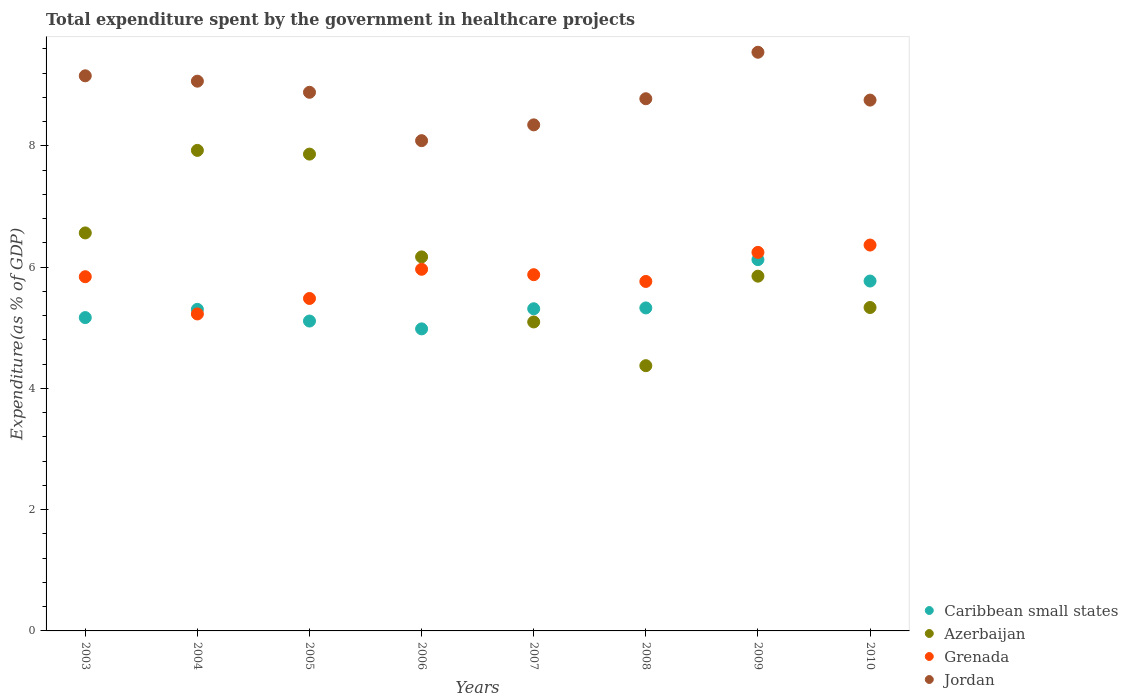How many different coloured dotlines are there?
Your answer should be very brief. 4. What is the total expenditure spent by the government in healthcare projects in Jordan in 2008?
Your answer should be very brief. 8.78. Across all years, what is the maximum total expenditure spent by the government in healthcare projects in Grenada?
Your answer should be very brief. 6.36. Across all years, what is the minimum total expenditure spent by the government in healthcare projects in Grenada?
Offer a very short reply. 5.23. What is the total total expenditure spent by the government in healthcare projects in Azerbaijan in the graph?
Provide a succinct answer. 49.17. What is the difference between the total expenditure spent by the government in healthcare projects in Azerbaijan in 2005 and that in 2006?
Provide a succinct answer. 1.7. What is the difference between the total expenditure spent by the government in healthcare projects in Jordan in 2003 and the total expenditure spent by the government in healthcare projects in Grenada in 2009?
Make the answer very short. 2.91. What is the average total expenditure spent by the government in healthcare projects in Grenada per year?
Your answer should be very brief. 5.84. In the year 2007, what is the difference between the total expenditure spent by the government in healthcare projects in Grenada and total expenditure spent by the government in healthcare projects in Azerbaijan?
Your answer should be very brief. 0.78. In how many years, is the total expenditure spent by the government in healthcare projects in Caribbean small states greater than 2.8 %?
Your response must be concise. 8. What is the ratio of the total expenditure spent by the government in healthcare projects in Grenada in 2007 to that in 2009?
Ensure brevity in your answer.  0.94. Is the total expenditure spent by the government in healthcare projects in Azerbaijan in 2007 less than that in 2010?
Keep it short and to the point. Yes. What is the difference between the highest and the second highest total expenditure spent by the government in healthcare projects in Azerbaijan?
Make the answer very short. 0.06. What is the difference between the highest and the lowest total expenditure spent by the government in healthcare projects in Azerbaijan?
Provide a succinct answer. 3.55. Is the sum of the total expenditure spent by the government in healthcare projects in Grenada in 2005 and 2009 greater than the maximum total expenditure spent by the government in healthcare projects in Caribbean small states across all years?
Your answer should be compact. Yes. Is it the case that in every year, the sum of the total expenditure spent by the government in healthcare projects in Jordan and total expenditure spent by the government in healthcare projects in Grenada  is greater than the total expenditure spent by the government in healthcare projects in Azerbaijan?
Your answer should be very brief. Yes. Is the total expenditure spent by the government in healthcare projects in Azerbaijan strictly greater than the total expenditure spent by the government in healthcare projects in Jordan over the years?
Your response must be concise. No. Is the total expenditure spent by the government in healthcare projects in Grenada strictly less than the total expenditure spent by the government in healthcare projects in Caribbean small states over the years?
Offer a terse response. No. How many years are there in the graph?
Your response must be concise. 8. Where does the legend appear in the graph?
Your answer should be very brief. Bottom right. How many legend labels are there?
Give a very brief answer. 4. How are the legend labels stacked?
Your answer should be very brief. Vertical. What is the title of the graph?
Ensure brevity in your answer.  Total expenditure spent by the government in healthcare projects. What is the label or title of the Y-axis?
Your response must be concise. Expenditure(as % of GDP). What is the Expenditure(as % of GDP) of Caribbean small states in 2003?
Provide a short and direct response. 5.17. What is the Expenditure(as % of GDP) in Azerbaijan in 2003?
Ensure brevity in your answer.  6.56. What is the Expenditure(as % of GDP) of Grenada in 2003?
Your response must be concise. 5.84. What is the Expenditure(as % of GDP) of Jordan in 2003?
Make the answer very short. 9.15. What is the Expenditure(as % of GDP) of Caribbean small states in 2004?
Make the answer very short. 5.3. What is the Expenditure(as % of GDP) in Azerbaijan in 2004?
Make the answer very short. 7.92. What is the Expenditure(as % of GDP) of Grenada in 2004?
Your answer should be very brief. 5.23. What is the Expenditure(as % of GDP) of Jordan in 2004?
Ensure brevity in your answer.  9.07. What is the Expenditure(as % of GDP) of Caribbean small states in 2005?
Ensure brevity in your answer.  5.11. What is the Expenditure(as % of GDP) in Azerbaijan in 2005?
Your answer should be very brief. 7.86. What is the Expenditure(as % of GDP) of Grenada in 2005?
Offer a very short reply. 5.48. What is the Expenditure(as % of GDP) of Jordan in 2005?
Ensure brevity in your answer.  8.88. What is the Expenditure(as % of GDP) of Caribbean small states in 2006?
Offer a very short reply. 4.98. What is the Expenditure(as % of GDP) of Azerbaijan in 2006?
Offer a very short reply. 6.17. What is the Expenditure(as % of GDP) of Grenada in 2006?
Give a very brief answer. 5.96. What is the Expenditure(as % of GDP) of Jordan in 2006?
Ensure brevity in your answer.  8.08. What is the Expenditure(as % of GDP) in Caribbean small states in 2007?
Your answer should be compact. 5.31. What is the Expenditure(as % of GDP) of Azerbaijan in 2007?
Your answer should be compact. 5.1. What is the Expenditure(as % of GDP) in Grenada in 2007?
Keep it short and to the point. 5.87. What is the Expenditure(as % of GDP) of Jordan in 2007?
Provide a short and direct response. 8.35. What is the Expenditure(as % of GDP) in Caribbean small states in 2008?
Provide a succinct answer. 5.33. What is the Expenditure(as % of GDP) in Azerbaijan in 2008?
Your response must be concise. 4.37. What is the Expenditure(as % of GDP) in Grenada in 2008?
Provide a succinct answer. 5.76. What is the Expenditure(as % of GDP) of Jordan in 2008?
Keep it short and to the point. 8.78. What is the Expenditure(as % of GDP) in Caribbean small states in 2009?
Provide a succinct answer. 6.12. What is the Expenditure(as % of GDP) in Azerbaijan in 2009?
Provide a succinct answer. 5.85. What is the Expenditure(as % of GDP) of Grenada in 2009?
Give a very brief answer. 6.24. What is the Expenditure(as % of GDP) of Jordan in 2009?
Offer a terse response. 9.54. What is the Expenditure(as % of GDP) in Caribbean small states in 2010?
Keep it short and to the point. 5.77. What is the Expenditure(as % of GDP) in Azerbaijan in 2010?
Offer a terse response. 5.33. What is the Expenditure(as % of GDP) in Grenada in 2010?
Your answer should be compact. 6.36. What is the Expenditure(as % of GDP) of Jordan in 2010?
Offer a terse response. 8.75. Across all years, what is the maximum Expenditure(as % of GDP) of Caribbean small states?
Provide a short and direct response. 6.12. Across all years, what is the maximum Expenditure(as % of GDP) of Azerbaijan?
Your answer should be very brief. 7.92. Across all years, what is the maximum Expenditure(as % of GDP) of Grenada?
Keep it short and to the point. 6.36. Across all years, what is the maximum Expenditure(as % of GDP) of Jordan?
Your response must be concise. 9.54. Across all years, what is the minimum Expenditure(as % of GDP) in Caribbean small states?
Offer a very short reply. 4.98. Across all years, what is the minimum Expenditure(as % of GDP) in Azerbaijan?
Offer a terse response. 4.37. Across all years, what is the minimum Expenditure(as % of GDP) in Grenada?
Offer a terse response. 5.23. Across all years, what is the minimum Expenditure(as % of GDP) of Jordan?
Offer a terse response. 8.08. What is the total Expenditure(as % of GDP) in Caribbean small states in the graph?
Make the answer very short. 43.09. What is the total Expenditure(as % of GDP) in Azerbaijan in the graph?
Keep it short and to the point. 49.17. What is the total Expenditure(as % of GDP) in Grenada in the graph?
Offer a very short reply. 46.76. What is the total Expenditure(as % of GDP) of Jordan in the graph?
Offer a very short reply. 70.61. What is the difference between the Expenditure(as % of GDP) in Caribbean small states in 2003 and that in 2004?
Keep it short and to the point. -0.14. What is the difference between the Expenditure(as % of GDP) of Azerbaijan in 2003 and that in 2004?
Provide a succinct answer. -1.36. What is the difference between the Expenditure(as % of GDP) in Grenada in 2003 and that in 2004?
Offer a very short reply. 0.61. What is the difference between the Expenditure(as % of GDP) of Jordan in 2003 and that in 2004?
Your response must be concise. 0.09. What is the difference between the Expenditure(as % of GDP) in Caribbean small states in 2003 and that in 2005?
Your answer should be very brief. 0.06. What is the difference between the Expenditure(as % of GDP) in Grenada in 2003 and that in 2005?
Make the answer very short. 0.36. What is the difference between the Expenditure(as % of GDP) of Jordan in 2003 and that in 2005?
Your answer should be very brief. 0.27. What is the difference between the Expenditure(as % of GDP) in Caribbean small states in 2003 and that in 2006?
Offer a terse response. 0.19. What is the difference between the Expenditure(as % of GDP) in Azerbaijan in 2003 and that in 2006?
Keep it short and to the point. 0.4. What is the difference between the Expenditure(as % of GDP) of Grenada in 2003 and that in 2006?
Offer a terse response. -0.12. What is the difference between the Expenditure(as % of GDP) in Jordan in 2003 and that in 2006?
Make the answer very short. 1.07. What is the difference between the Expenditure(as % of GDP) of Caribbean small states in 2003 and that in 2007?
Provide a short and direct response. -0.15. What is the difference between the Expenditure(as % of GDP) in Azerbaijan in 2003 and that in 2007?
Your answer should be compact. 1.47. What is the difference between the Expenditure(as % of GDP) of Grenada in 2003 and that in 2007?
Your answer should be compact. -0.03. What is the difference between the Expenditure(as % of GDP) of Jordan in 2003 and that in 2007?
Make the answer very short. 0.81. What is the difference between the Expenditure(as % of GDP) in Caribbean small states in 2003 and that in 2008?
Provide a succinct answer. -0.16. What is the difference between the Expenditure(as % of GDP) of Azerbaijan in 2003 and that in 2008?
Your response must be concise. 2.19. What is the difference between the Expenditure(as % of GDP) of Grenada in 2003 and that in 2008?
Offer a very short reply. 0.08. What is the difference between the Expenditure(as % of GDP) in Jordan in 2003 and that in 2008?
Your answer should be compact. 0.38. What is the difference between the Expenditure(as % of GDP) in Caribbean small states in 2003 and that in 2009?
Provide a short and direct response. -0.96. What is the difference between the Expenditure(as % of GDP) in Azerbaijan in 2003 and that in 2009?
Provide a short and direct response. 0.71. What is the difference between the Expenditure(as % of GDP) in Grenada in 2003 and that in 2009?
Ensure brevity in your answer.  -0.4. What is the difference between the Expenditure(as % of GDP) in Jordan in 2003 and that in 2009?
Provide a succinct answer. -0.39. What is the difference between the Expenditure(as % of GDP) in Caribbean small states in 2003 and that in 2010?
Keep it short and to the point. -0.6. What is the difference between the Expenditure(as % of GDP) in Azerbaijan in 2003 and that in 2010?
Provide a succinct answer. 1.23. What is the difference between the Expenditure(as % of GDP) of Grenada in 2003 and that in 2010?
Keep it short and to the point. -0.52. What is the difference between the Expenditure(as % of GDP) of Jordan in 2003 and that in 2010?
Ensure brevity in your answer.  0.4. What is the difference between the Expenditure(as % of GDP) in Caribbean small states in 2004 and that in 2005?
Keep it short and to the point. 0.19. What is the difference between the Expenditure(as % of GDP) in Azerbaijan in 2004 and that in 2005?
Provide a short and direct response. 0.06. What is the difference between the Expenditure(as % of GDP) in Grenada in 2004 and that in 2005?
Offer a very short reply. -0.26. What is the difference between the Expenditure(as % of GDP) of Jordan in 2004 and that in 2005?
Your answer should be compact. 0.18. What is the difference between the Expenditure(as % of GDP) of Caribbean small states in 2004 and that in 2006?
Your response must be concise. 0.32. What is the difference between the Expenditure(as % of GDP) in Azerbaijan in 2004 and that in 2006?
Your answer should be very brief. 1.76. What is the difference between the Expenditure(as % of GDP) of Grenada in 2004 and that in 2006?
Your answer should be very brief. -0.74. What is the difference between the Expenditure(as % of GDP) of Jordan in 2004 and that in 2006?
Your answer should be very brief. 0.98. What is the difference between the Expenditure(as % of GDP) in Caribbean small states in 2004 and that in 2007?
Your answer should be compact. -0.01. What is the difference between the Expenditure(as % of GDP) in Azerbaijan in 2004 and that in 2007?
Your response must be concise. 2.83. What is the difference between the Expenditure(as % of GDP) in Grenada in 2004 and that in 2007?
Keep it short and to the point. -0.65. What is the difference between the Expenditure(as % of GDP) of Jordan in 2004 and that in 2007?
Your answer should be very brief. 0.72. What is the difference between the Expenditure(as % of GDP) of Caribbean small states in 2004 and that in 2008?
Give a very brief answer. -0.02. What is the difference between the Expenditure(as % of GDP) of Azerbaijan in 2004 and that in 2008?
Your response must be concise. 3.55. What is the difference between the Expenditure(as % of GDP) of Grenada in 2004 and that in 2008?
Your answer should be very brief. -0.54. What is the difference between the Expenditure(as % of GDP) in Jordan in 2004 and that in 2008?
Keep it short and to the point. 0.29. What is the difference between the Expenditure(as % of GDP) of Caribbean small states in 2004 and that in 2009?
Your answer should be very brief. -0.82. What is the difference between the Expenditure(as % of GDP) of Azerbaijan in 2004 and that in 2009?
Provide a succinct answer. 2.07. What is the difference between the Expenditure(as % of GDP) of Grenada in 2004 and that in 2009?
Ensure brevity in your answer.  -1.02. What is the difference between the Expenditure(as % of GDP) of Jordan in 2004 and that in 2009?
Offer a very short reply. -0.48. What is the difference between the Expenditure(as % of GDP) in Caribbean small states in 2004 and that in 2010?
Offer a very short reply. -0.47. What is the difference between the Expenditure(as % of GDP) in Azerbaijan in 2004 and that in 2010?
Give a very brief answer. 2.59. What is the difference between the Expenditure(as % of GDP) in Grenada in 2004 and that in 2010?
Offer a very short reply. -1.14. What is the difference between the Expenditure(as % of GDP) in Jordan in 2004 and that in 2010?
Provide a short and direct response. 0.31. What is the difference between the Expenditure(as % of GDP) of Caribbean small states in 2005 and that in 2006?
Provide a short and direct response. 0.13. What is the difference between the Expenditure(as % of GDP) in Azerbaijan in 2005 and that in 2006?
Offer a very short reply. 1.7. What is the difference between the Expenditure(as % of GDP) in Grenada in 2005 and that in 2006?
Offer a very short reply. -0.48. What is the difference between the Expenditure(as % of GDP) in Jordan in 2005 and that in 2006?
Your answer should be very brief. 0.8. What is the difference between the Expenditure(as % of GDP) of Caribbean small states in 2005 and that in 2007?
Make the answer very short. -0.2. What is the difference between the Expenditure(as % of GDP) in Azerbaijan in 2005 and that in 2007?
Give a very brief answer. 2.77. What is the difference between the Expenditure(as % of GDP) of Grenada in 2005 and that in 2007?
Ensure brevity in your answer.  -0.39. What is the difference between the Expenditure(as % of GDP) in Jordan in 2005 and that in 2007?
Give a very brief answer. 0.54. What is the difference between the Expenditure(as % of GDP) of Caribbean small states in 2005 and that in 2008?
Your response must be concise. -0.22. What is the difference between the Expenditure(as % of GDP) of Azerbaijan in 2005 and that in 2008?
Ensure brevity in your answer.  3.49. What is the difference between the Expenditure(as % of GDP) in Grenada in 2005 and that in 2008?
Your response must be concise. -0.28. What is the difference between the Expenditure(as % of GDP) of Jordan in 2005 and that in 2008?
Your answer should be very brief. 0.11. What is the difference between the Expenditure(as % of GDP) of Caribbean small states in 2005 and that in 2009?
Offer a very short reply. -1.01. What is the difference between the Expenditure(as % of GDP) in Azerbaijan in 2005 and that in 2009?
Offer a very short reply. 2.01. What is the difference between the Expenditure(as % of GDP) in Grenada in 2005 and that in 2009?
Your answer should be very brief. -0.76. What is the difference between the Expenditure(as % of GDP) in Jordan in 2005 and that in 2009?
Your response must be concise. -0.66. What is the difference between the Expenditure(as % of GDP) of Caribbean small states in 2005 and that in 2010?
Your answer should be very brief. -0.66. What is the difference between the Expenditure(as % of GDP) of Azerbaijan in 2005 and that in 2010?
Ensure brevity in your answer.  2.53. What is the difference between the Expenditure(as % of GDP) in Grenada in 2005 and that in 2010?
Your answer should be very brief. -0.88. What is the difference between the Expenditure(as % of GDP) in Jordan in 2005 and that in 2010?
Provide a short and direct response. 0.13. What is the difference between the Expenditure(as % of GDP) of Caribbean small states in 2006 and that in 2007?
Provide a succinct answer. -0.33. What is the difference between the Expenditure(as % of GDP) in Azerbaijan in 2006 and that in 2007?
Provide a short and direct response. 1.07. What is the difference between the Expenditure(as % of GDP) in Grenada in 2006 and that in 2007?
Give a very brief answer. 0.09. What is the difference between the Expenditure(as % of GDP) of Jordan in 2006 and that in 2007?
Your answer should be very brief. -0.26. What is the difference between the Expenditure(as % of GDP) in Caribbean small states in 2006 and that in 2008?
Provide a short and direct response. -0.35. What is the difference between the Expenditure(as % of GDP) of Azerbaijan in 2006 and that in 2008?
Your answer should be compact. 1.79. What is the difference between the Expenditure(as % of GDP) in Grenada in 2006 and that in 2008?
Ensure brevity in your answer.  0.2. What is the difference between the Expenditure(as % of GDP) in Jordan in 2006 and that in 2008?
Provide a succinct answer. -0.69. What is the difference between the Expenditure(as % of GDP) in Caribbean small states in 2006 and that in 2009?
Your response must be concise. -1.14. What is the difference between the Expenditure(as % of GDP) in Azerbaijan in 2006 and that in 2009?
Provide a short and direct response. 0.32. What is the difference between the Expenditure(as % of GDP) of Grenada in 2006 and that in 2009?
Your response must be concise. -0.28. What is the difference between the Expenditure(as % of GDP) in Jordan in 2006 and that in 2009?
Your response must be concise. -1.46. What is the difference between the Expenditure(as % of GDP) in Caribbean small states in 2006 and that in 2010?
Your answer should be compact. -0.79. What is the difference between the Expenditure(as % of GDP) of Azerbaijan in 2006 and that in 2010?
Keep it short and to the point. 0.83. What is the difference between the Expenditure(as % of GDP) of Grenada in 2006 and that in 2010?
Your answer should be very brief. -0.4. What is the difference between the Expenditure(as % of GDP) of Jordan in 2006 and that in 2010?
Offer a very short reply. -0.67. What is the difference between the Expenditure(as % of GDP) in Caribbean small states in 2007 and that in 2008?
Provide a short and direct response. -0.01. What is the difference between the Expenditure(as % of GDP) of Azerbaijan in 2007 and that in 2008?
Provide a short and direct response. 0.72. What is the difference between the Expenditure(as % of GDP) of Grenada in 2007 and that in 2008?
Your response must be concise. 0.11. What is the difference between the Expenditure(as % of GDP) of Jordan in 2007 and that in 2008?
Give a very brief answer. -0.43. What is the difference between the Expenditure(as % of GDP) in Caribbean small states in 2007 and that in 2009?
Make the answer very short. -0.81. What is the difference between the Expenditure(as % of GDP) of Azerbaijan in 2007 and that in 2009?
Provide a succinct answer. -0.76. What is the difference between the Expenditure(as % of GDP) in Grenada in 2007 and that in 2009?
Provide a short and direct response. -0.37. What is the difference between the Expenditure(as % of GDP) of Jordan in 2007 and that in 2009?
Give a very brief answer. -1.2. What is the difference between the Expenditure(as % of GDP) in Caribbean small states in 2007 and that in 2010?
Offer a terse response. -0.46. What is the difference between the Expenditure(as % of GDP) of Azerbaijan in 2007 and that in 2010?
Provide a succinct answer. -0.24. What is the difference between the Expenditure(as % of GDP) in Grenada in 2007 and that in 2010?
Give a very brief answer. -0.49. What is the difference between the Expenditure(as % of GDP) of Jordan in 2007 and that in 2010?
Provide a short and direct response. -0.41. What is the difference between the Expenditure(as % of GDP) of Caribbean small states in 2008 and that in 2009?
Your answer should be very brief. -0.8. What is the difference between the Expenditure(as % of GDP) of Azerbaijan in 2008 and that in 2009?
Make the answer very short. -1.48. What is the difference between the Expenditure(as % of GDP) in Grenada in 2008 and that in 2009?
Ensure brevity in your answer.  -0.48. What is the difference between the Expenditure(as % of GDP) of Jordan in 2008 and that in 2009?
Provide a short and direct response. -0.77. What is the difference between the Expenditure(as % of GDP) of Caribbean small states in 2008 and that in 2010?
Make the answer very short. -0.44. What is the difference between the Expenditure(as % of GDP) of Azerbaijan in 2008 and that in 2010?
Make the answer very short. -0.96. What is the difference between the Expenditure(as % of GDP) in Grenada in 2008 and that in 2010?
Ensure brevity in your answer.  -0.6. What is the difference between the Expenditure(as % of GDP) of Jordan in 2008 and that in 2010?
Provide a succinct answer. 0.02. What is the difference between the Expenditure(as % of GDP) in Caribbean small states in 2009 and that in 2010?
Provide a succinct answer. 0.35. What is the difference between the Expenditure(as % of GDP) of Azerbaijan in 2009 and that in 2010?
Your answer should be very brief. 0.52. What is the difference between the Expenditure(as % of GDP) in Grenada in 2009 and that in 2010?
Your answer should be very brief. -0.12. What is the difference between the Expenditure(as % of GDP) of Jordan in 2009 and that in 2010?
Keep it short and to the point. 0.79. What is the difference between the Expenditure(as % of GDP) of Caribbean small states in 2003 and the Expenditure(as % of GDP) of Azerbaijan in 2004?
Provide a succinct answer. -2.76. What is the difference between the Expenditure(as % of GDP) of Caribbean small states in 2003 and the Expenditure(as % of GDP) of Grenada in 2004?
Give a very brief answer. -0.06. What is the difference between the Expenditure(as % of GDP) in Caribbean small states in 2003 and the Expenditure(as % of GDP) in Jordan in 2004?
Your answer should be very brief. -3.9. What is the difference between the Expenditure(as % of GDP) in Azerbaijan in 2003 and the Expenditure(as % of GDP) in Grenada in 2004?
Keep it short and to the point. 1.34. What is the difference between the Expenditure(as % of GDP) of Azerbaijan in 2003 and the Expenditure(as % of GDP) of Jordan in 2004?
Your answer should be very brief. -2.5. What is the difference between the Expenditure(as % of GDP) in Grenada in 2003 and the Expenditure(as % of GDP) in Jordan in 2004?
Ensure brevity in your answer.  -3.22. What is the difference between the Expenditure(as % of GDP) in Caribbean small states in 2003 and the Expenditure(as % of GDP) in Azerbaijan in 2005?
Give a very brief answer. -2.7. What is the difference between the Expenditure(as % of GDP) of Caribbean small states in 2003 and the Expenditure(as % of GDP) of Grenada in 2005?
Your response must be concise. -0.32. What is the difference between the Expenditure(as % of GDP) in Caribbean small states in 2003 and the Expenditure(as % of GDP) in Jordan in 2005?
Keep it short and to the point. -3.72. What is the difference between the Expenditure(as % of GDP) of Azerbaijan in 2003 and the Expenditure(as % of GDP) of Grenada in 2005?
Provide a short and direct response. 1.08. What is the difference between the Expenditure(as % of GDP) in Azerbaijan in 2003 and the Expenditure(as % of GDP) in Jordan in 2005?
Offer a very short reply. -2.32. What is the difference between the Expenditure(as % of GDP) in Grenada in 2003 and the Expenditure(as % of GDP) in Jordan in 2005?
Ensure brevity in your answer.  -3.04. What is the difference between the Expenditure(as % of GDP) of Caribbean small states in 2003 and the Expenditure(as % of GDP) of Azerbaijan in 2006?
Your answer should be very brief. -1. What is the difference between the Expenditure(as % of GDP) in Caribbean small states in 2003 and the Expenditure(as % of GDP) in Grenada in 2006?
Give a very brief answer. -0.8. What is the difference between the Expenditure(as % of GDP) of Caribbean small states in 2003 and the Expenditure(as % of GDP) of Jordan in 2006?
Ensure brevity in your answer.  -2.92. What is the difference between the Expenditure(as % of GDP) in Azerbaijan in 2003 and the Expenditure(as % of GDP) in Grenada in 2006?
Offer a very short reply. 0.6. What is the difference between the Expenditure(as % of GDP) of Azerbaijan in 2003 and the Expenditure(as % of GDP) of Jordan in 2006?
Ensure brevity in your answer.  -1.52. What is the difference between the Expenditure(as % of GDP) in Grenada in 2003 and the Expenditure(as % of GDP) in Jordan in 2006?
Keep it short and to the point. -2.24. What is the difference between the Expenditure(as % of GDP) of Caribbean small states in 2003 and the Expenditure(as % of GDP) of Azerbaijan in 2007?
Your answer should be compact. 0.07. What is the difference between the Expenditure(as % of GDP) in Caribbean small states in 2003 and the Expenditure(as % of GDP) in Grenada in 2007?
Ensure brevity in your answer.  -0.71. What is the difference between the Expenditure(as % of GDP) in Caribbean small states in 2003 and the Expenditure(as % of GDP) in Jordan in 2007?
Your answer should be compact. -3.18. What is the difference between the Expenditure(as % of GDP) of Azerbaijan in 2003 and the Expenditure(as % of GDP) of Grenada in 2007?
Offer a very short reply. 0.69. What is the difference between the Expenditure(as % of GDP) of Azerbaijan in 2003 and the Expenditure(as % of GDP) of Jordan in 2007?
Your answer should be very brief. -1.78. What is the difference between the Expenditure(as % of GDP) in Grenada in 2003 and the Expenditure(as % of GDP) in Jordan in 2007?
Make the answer very short. -2.5. What is the difference between the Expenditure(as % of GDP) in Caribbean small states in 2003 and the Expenditure(as % of GDP) in Azerbaijan in 2008?
Provide a short and direct response. 0.79. What is the difference between the Expenditure(as % of GDP) in Caribbean small states in 2003 and the Expenditure(as % of GDP) in Grenada in 2008?
Offer a terse response. -0.6. What is the difference between the Expenditure(as % of GDP) in Caribbean small states in 2003 and the Expenditure(as % of GDP) in Jordan in 2008?
Provide a short and direct response. -3.61. What is the difference between the Expenditure(as % of GDP) of Azerbaijan in 2003 and the Expenditure(as % of GDP) of Grenada in 2008?
Your answer should be compact. 0.8. What is the difference between the Expenditure(as % of GDP) in Azerbaijan in 2003 and the Expenditure(as % of GDP) in Jordan in 2008?
Make the answer very short. -2.21. What is the difference between the Expenditure(as % of GDP) in Grenada in 2003 and the Expenditure(as % of GDP) in Jordan in 2008?
Make the answer very short. -2.94. What is the difference between the Expenditure(as % of GDP) in Caribbean small states in 2003 and the Expenditure(as % of GDP) in Azerbaijan in 2009?
Ensure brevity in your answer.  -0.68. What is the difference between the Expenditure(as % of GDP) in Caribbean small states in 2003 and the Expenditure(as % of GDP) in Grenada in 2009?
Your answer should be compact. -1.08. What is the difference between the Expenditure(as % of GDP) of Caribbean small states in 2003 and the Expenditure(as % of GDP) of Jordan in 2009?
Your response must be concise. -4.38. What is the difference between the Expenditure(as % of GDP) of Azerbaijan in 2003 and the Expenditure(as % of GDP) of Grenada in 2009?
Provide a succinct answer. 0.32. What is the difference between the Expenditure(as % of GDP) of Azerbaijan in 2003 and the Expenditure(as % of GDP) of Jordan in 2009?
Keep it short and to the point. -2.98. What is the difference between the Expenditure(as % of GDP) of Grenada in 2003 and the Expenditure(as % of GDP) of Jordan in 2009?
Your response must be concise. -3.7. What is the difference between the Expenditure(as % of GDP) of Caribbean small states in 2003 and the Expenditure(as % of GDP) of Azerbaijan in 2010?
Your answer should be very brief. -0.17. What is the difference between the Expenditure(as % of GDP) in Caribbean small states in 2003 and the Expenditure(as % of GDP) in Grenada in 2010?
Offer a very short reply. -1.2. What is the difference between the Expenditure(as % of GDP) of Caribbean small states in 2003 and the Expenditure(as % of GDP) of Jordan in 2010?
Provide a succinct answer. -3.59. What is the difference between the Expenditure(as % of GDP) in Azerbaijan in 2003 and the Expenditure(as % of GDP) in Grenada in 2010?
Your response must be concise. 0.2. What is the difference between the Expenditure(as % of GDP) of Azerbaijan in 2003 and the Expenditure(as % of GDP) of Jordan in 2010?
Your answer should be compact. -2.19. What is the difference between the Expenditure(as % of GDP) of Grenada in 2003 and the Expenditure(as % of GDP) of Jordan in 2010?
Your answer should be compact. -2.91. What is the difference between the Expenditure(as % of GDP) of Caribbean small states in 2004 and the Expenditure(as % of GDP) of Azerbaijan in 2005?
Offer a terse response. -2.56. What is the difference between the Expenditure(as % of GDP) of Caribbean small states in 2004 and the Expenditure(as % of GDP) of Grenada in 2005?
Your answer should be compact. -0.18. What is the difference between the Expenditure(as % of GDP) in Caribbean small states in 2004 and the Expenditure(as % of GDP) in Jordan in 2005?
Make the answer very short. -3.58. What is the difference between the Expenditure(as % of GDP) of Azerbaijan in 2004 and the Expenditure(as % of GDP) of Grenada in 2005?
Your answer should be very brief. 2.44. What is the difference between the Expenditure(as % of GDP) in Azerbaijan in 2004 and the Expenditure(as % of GDP) in Jordan in 2005?
Keep it short and to the point. -0.96. What is the difference between the Expenditure(as % of GDP) of Grenada in 2004 and the Expenditure(as % of GDP) of Jordan in 2005?
Ensure brevity in your answer.  -3.66. What is the difference between the Expenditure(as % of GDP) of Caribbean small states in 2004 and the Expenditure(as % of GDP) of Azerbaijan in 2006?
Your answer should be very brief. -0.86. What is the difference between the Expenditure(as % of GDP) of Caribbean small states in 2004 and the Expenditure(as % of GDP) of Grenada in 2006?
Provide a short and direct response. -0.66. What is the difference between the Expenditure(as % of GDP) of Caribbean small states in 2004 and the Expenditure(as % of GDP) of Jordan in 2006?
Your response must be concise. -2.78. What is the difference between the Expenditure(as % of GDP) of Azerbaijan in 2004 and the Expenditure(as % of GDP) of Grenada in 2006?
Offer a very short reply. 1.96. What is the difference between the Expenditure(as % of GDP) in Azerbaijan in 2004 and the Expenditure(as % of GDP) in Jordan in 2006?
Make the answer very short. -0.16. What is the difference between the Expenditure(as % of GDP) of Grenada in 2004 and the Expenditure(as % of GDP) of Jordan in 2006?
Give a very brief answer. -2.86. What is the difference between the Expenditure(as % of GDP) of Caribbean small states in 2004 and the Expenditure(as % of GDP) of Azerbaijan in 2007?
Offer a very short reply. 0.21. What is the difference between the Expenditure(as % of GDP) of Caribbean small states in 2004 and the Expenditure(as % of GDP) of Grenada in 2007?
Offer a terse response. -0.57. What is the difference between the Expenditure(as % of GDP) in Caribbean small states in 2004 and the Expenditure(as % of GDP) in Jordan in 2007?
Offer a terse response. -3.04. What is the difference between the Expenditure(as % of GDP) in Azerbaijan in 2004 and the Expenditure(as % of GDP) in Grenada in 2007?
Your answer should be compact. 2.05. What is the difference between the Expenditure(as % of GDP) of Azerbaijan in 2004 and the Expenditure(as % of GDP) of Jordan in 2007?
Ensure brevity in your answer.  -0.42. What is the difference between the Expenditure(as % of GDP) in Grenada in 2004 and the Expenditure(as % of GDP) in Jordan in 2007?
Give a very brief answer. -3.12. What is the difference between the Expenditure(as % of GDP) in Caribbean small states in 2004 and the Expenditure(as % of GDP) in Azerbaijan in 2008?
Provide a succinct answer. 0.93. What is the difference between the Expenditure(as % of GDP) in Caribbean small states in 2004 and the Expenditure(as % of GDP) in Grenada in 2008?
Give a very brief answer. -0.46. What is the difference between the Expenditure(as % of GDP) in Caribbean small states in 2004 and the Expenditure(as % of GDP) in Jordan in 2008?
Provide a short and direct response. -3.47. What is the difference between the Expenditure(as % of GDP) of Azerbaijan in 2004 and the Expenditure(as % of GDP) of Grenada in 2008?
Give a very brief answer. 2.16. What is the difference between the Expenditure(as % of GDP) in Azerbaijan in 2004 and the Expenditure(as % of GDP) in Jordan in 2008?
Provide a succinct answer. -0.85. What is the difference between the Expenditure(as % of GDP) in Grenada in 2004 and the Expenditure(as % of GDP) in Jordan in 2008?
Provide a succinct answer. -3.55. What is the difference between the Expenditure(as % of GDP) in Caribbean small states in 2004 and the Expenditure(as % of GDP) in Azerbaijan in 2009?
Your answer should be very brief. -0.55. What is the difference between the Expenditure(as % of GDP) of Caribbean small states in 2004 and the Expenditure(as % of GDP) of Grenada in 2009?
Provide a succinct answer. -0.94. What is the difference between the Expenditure(as % of GDP) in Caribbean small states in 2004 and the Expenditure(as % of GDP) in Jordan in 2009?
Your response must be concise. -4.24. What is the difference between the Expenditure(as % of GDP) in Azerbaijan in 2004 and the Expenditure(as % of GDP) in Grenada in 2009?
Your response must be concise. 1.68. What is the difference between the Expenditure(as % of GDP) in Azerbaijan in 2004 and the Expenditure(as % of GDP) in Jordan in 2009?
Your answer should be very brief. -1.62. What is the difference between the Expenditure(as % of GDP) in Grenada in 2004 and the Expenditure(as % of GDP) in Jordan in 2009?
Your response must be concise. -4.32. What is the difference between the Expenditure(as % of GDP) of Caribbean small states in 2004 and the Expenditure(as % of GDP) of Azerbaijan in 2010?
Offer a terse response. -0.03. What is the difference between the Expenditure(as % of GDP) in Caribbean small states in 2004 and the Expenditure(as % of GDP) in Grenada in 2010?
Make the answer very short. -1.06. What is the difference between the Expenditure(as % of GDP) of Caribbean small states in 2004 and the Expenditure(as % of GDP) of Jordan in 2010?
Provide a succinct answer. -3.45. What is the difference between the Expenditure(as % of GDP) of Azerbaijan in 2004 and the Expenditure(as % of GDP) of Grenada in 2010?
Give a very brief answer. 1.56. What is the difference between the Expenditure(as % of GDP) of Azerbaijan in 2004 and the Expenditure(as % of GDP) of Jordan in 2010?
Give a very brief answer. -0.83. What is the difference between the Expenditure(as % of GDP) in Grenada in 2004 and the Expenditure(as % of GDP) in Jordan in 2010?
Provide a succinct answer. -3.53. What is the difference between the Expenditure(as % of GDP) of Caribbean small states in 2005 and the Expenditure(as % of GDP) of Azerbaijan in 2006?
Provide a succinct answer. -1.06. What is the difference between the Expenditure(as % of GDP) in Caribbean small states in 2005 and the Expenditure(as % of GDP) in Grenada in 2006?
Your answer should be compact. -0.85. What is the difference between the Expenditure(as % of GDP) in Caribbean small states in 2005 and the Expenditure(as % of GDP) in Jordan in 2006?
Your answer should be very brief. -2.97. What is the difference between the Expenditure(as % of GDP) in Azerbaijan in 2005 and the Expenditure(as % of GDP) in Grenada in 2006?
Offer a very short reply. 1.9. What is the difference between the Expenditure(as % of GDP) in Azerbaijan in 2005 and the Expenditure(as % of GDP) in Jordan in 2006?
Give a very brief answer. -0.22. What is the difference between the Expenditure(as % of GDP) of Grenada in 2005 and the Expenditure(as % of GDP) of Jordan in 2006?
Your response must be concise. -2.6. What is the difference between the Expenditure(as % of GDP) of Caribbean small states in 2005 and the Expenditure(as % of GDP) of Azerbaijan in 2007?
Offer a terse response. 0.02. What is the difference between the Expenditure(as % of GDP) of Caribbean small states in 2005 and the Expenditure(as % of GDP) of Grenada in 2007?
Make the answer very short. -0.76. What is the difference between the Expenditure(as % of GDP) in Caribbean small states in 2005 and the Expenditure(as % of GDP) in Jordan in 2007?
Make the answer very short. -3.24. What is the difference between the Expenditure(as % of GDP) of Azerbaijan in 2005 and the Expenditure(as % of GDP) of Grenada in 2007?
Offer a terse response. 1.99. What is the difference between the Expenditure(as % of GDP) of Azerbaijan in 2005 and the Expenditure(as % of GDP) of Jordan in 2007?
Offer a very short reply. -0.48. What is the difference between the Expenditure(as % of GDP) in Grenada in 2005 and the Expenditure(as % of GDP) in Jordan in 2007?
Keep it short and to the point. -2.86. What is the difference between the Expenditure(as % of GDP) of Caribbean small states in 2005 and the Expenditure(as % of GDP) of Azerbaijan in 2008?
Offer a very short reply. 0.74. What is the difference between the Expenditure(as % of GDP) of Caribbean small states in 2005 and the Expenditure(as % of GDP) of Grenada in 2008?
Give a very brief answer. -0.65. What is the difference between the Expenditure(as % of GDP) of Caribbean small states in 2005 and the Expenditure(as % of GDP) of Jordan in 2008?
Make the answer very short. -3.67. What is the difference between the Expenditure(as % of GDP) in Azerbaijan in 2005 and the Expenditure(as % of GDP) in Jordan in 2008?
Provide a succinct answer. -0.91. What is the difference between the Expenditure(as % of GDP) of Grenada in 2005 and the Expenditure(as % of GDP) of Jordan in 2008?
Provide a short and direct response. -3.29. What is the difference between the Expenditure(as % of GDP) in Caribbean small states in 2005 and the Expenditure(as % of GDP) in Azerbaijan in 2009?
Offer a very short reply. -0.74. What is the difference between the Expenditure(as % of GDP) of Caribbean small states in 2005 and the Expenditure(as % of GDP) of Grenada in 2009?
Ensure brevity in your answer.  -1.13. What is the difference between the Expenditure(as % of GDP) of Caribbean small states in 2005 and the Expenditure(as % of GDP) of Jordan in 2009?
Your answer should be compact. -4.43. What is the difference between the Expenditure(as % of GDP) of Azerbaijan in 2005 and the Expenditure(as % of GDP) of Grenada in 2009?
Ensure brevity in your answer.  1.62. What is the difference between the Expenditure(as % of GDP) in Azerbaijan in 2005 and the Expenditure(as % of GDP) in Jordan in 2009?
Your response must be concise. -1.68. What is the difference between the Expenditure(as % of GDP) of Grenada in 2005 and the Expenditure(as % of GDP) of Jordan in 2009?
Give a very brief answer. -4.06. What is the difference between the Expenditure(as % of GDP) in Caribbean small states in 2005 and the Expenditure(as % of GDP) in Azerbaijan in 2010?
Ensure brevity in your answer.  -0.22. What is the difference between the Expenditure(as % of GDP) in Caribbean small states in 2005 and the Expenditure(as % of GDP) in Grenada in 2010?
Give a very brief answer. -1.25. What is the difference between the Expenditure(as % of GDP) in Caribbean small states in 2005 and the Expenditure(as % of GDP) in Jordan in 2010?
Your answer should be compact. -3.64. What is the difference between the Expenditure(as % of GDP) of Azerbaijan in 2005 and the Expenditure(as % of GDP) of Grenada in 2010?
Your response must be concise. 1.5. What is the difference between the Expenditure(as % of GDP) of Azerbaijan in 2005 and the Expenditure(as % of GDP) of Jordan in 2010?
Give a very brief answer. -0.89. What is the difference between the Expenditure(as % of GDP) in Grenada in 2005 and the Expenditure(as % of GDP) in Jordan in 2010?
Ensure brevity in your answer.  -3.27. What is the difference between the Expenditure(as % of GDP) in Caribbean small states in 2006 and the Expenditure(as % of GDP) in Azerbaijan in 2007?
Provide a succinct answer. -0.11. What is the difference between the Expenditure(as % of GDP) of Caribbean small states in 2006 and the Expenditure(as % of GDP) of Grenada in 2007?
Keep it short and to the point. -0.89. What is the difference between the Expenditure(as % of GDP) in Caribbean small states in 2006 and the Expenditure(as % of GDP) in Jordan in 2007?
Your answer should be compact. -3.36. What is the difference between the Expenditure(as % of GDP) in Azerbaijan in 2006 and the Expenditure(as % of GDP) in Grenada in 2007?
Keep it short and to the point. 0.29. What is the difference between the Expenditure(as % of GDP) of Azerbaijan in 2006 and the Expenditure(as % of GDP) of Jordan in 2007?
Provide a succinct answer. -2.18. What is the difference between the Expenditure(as % of GDP) in Grenada in 2006 and the Expenditure(as % of GDP) in Jordan in 2007?
Give a very brief answer. -2.38. What is the difference between the Expenditure(as % of GDP) of Caribbean small states in 2006 and the Expenditure(as % of GDP) of Azerbaijan in 2008?
Make the answer very short. 0.61. What is the difference between the Expenditure(as % of GDP) of Caribbean small states in 2006 and the Expenditure(as % of GDP) of Grenada in 2008?
Keep it short and to the point. -0.78. What is the difference between the Expenditure(as % of GDP) of Caribbean small states in 2006 and the Expenditure(as % of GDP) of Jordan in 2008?
Keep it short and to the point. -3.8. What is the difference between the Expenditure(as % of GDP) in Azerbaijan in 2006 and the Expenditure(as % of GDP) in Grenada in 2008?
Offer a terse response. 0.4. What is the difference between the Expenditure(as % of GDP) of Azerbaijan in 2006 and the Expenditure(as % of GDP) of Jordan in 2008?
Make the answer very short. -2.61. What is the difference between the Expenditure(as % of GDP) of Grenada in 2006 and the Expenditure(as % of GDP) of Jordan in 2008?
Give a very brief answer. -2.81. What is the difference between the Expenditure(as % of GDP) in Caribbean small states in 2006 and the Expenditure(as % of GDP) in Azerbaijan in 2009?
Keep it short and to the point. -0.87. What is the difference between the Expenditure(as % of GDP) of Caribbean small states in 2006 and the Expenditure(as % of GDP) of Grenada in 2009?
Keep it short and to the point. -1.26. What is the difference between the Expenditure(as % of GDP) in Caribbean small states in 2006 and the Expenditure(as % of GDP) in Jordan in 2009?
Provide a short and direct response. -4.56. What is the difference between the Expenditure(as % of GDP) in Azerbaijan in 2006 and the Expenditure(as % of GDP) in Grenada in 2009?
Your answer should be very brief. -0.07. What is the difference between the Expenditure(as % of GDP) of Azerbaijan in 2006 and the Expenditure(as % of GDP) of Jordan in 2009?
Make the answer very short. -3.38. What is the difference between the Expenditure(as % of GDP) of Grenada in 2006 and the Expenditure(as % of GDP) of Jordan in 2009?
Your response must be concise. -3.58. What is the difference between the Expenditure(as % of GDP) in Caribbean small states in 2006 and the Expenditure(as % of GDP) in Azerbaijan in 2010?
Offer a very short reply. -0.35. What is the difference between the Expenditure(as % of GDP) in Caribbean small states in 2006 and the Expenditure(as % of GDP) in Grenada in 2010?
Give a very brief answer. -1.38. What is the difference between the Expenditure(as % of GDP) in Caribbean small states in 2006 and the Expenditure(as % of GDP) in Jordan in 2010?
Your answer should be compact. -3.77. What is the difference between the Expenditure(as % of GDP) in Azerbaijan in 2006 and the Expenditure(as % of GDP) in Grenada in 2010?
Your answer should be compact. -0.2. What is the difference between the Expenditure(as % of GDP) of Azerbaijan in 2006 and the Expenditure(as % of GDP) of Jordan in 2010?
Give a very brief answer. -2.59. What is the difference between the Expenditure(as % of GDP) in Grenada in 2006 and the Expenditure(as % of GDP) in Jordan in 2010?
Your answer should be compact. -2.79. What is the difference between the Expenditure(as % of GDP) of Caribbean small states in 2007 and the Expenditure(as % of GDP) of Azerbaijan in 2008?
Provide a succinct answer. 0.94. What is the difference between the Expenditure(as % of GDP) of Caribbean small states in 2007 and the Expenditure(as % of GDP) of Grenada in 2008?
Offer a terse response. -0.45. What is the difference between the Expenditure(as % of GDP) in Caribbean small states in 2007 and the Expenditure(as % of GDP) in Jordan in 2008?
Give a very brief answer. -3.46. What is the difference between the Expenditure(as % of GDP) of Azerbaijan in 2007 and the Expenditure(as % of GDP) of Grenada in 2008?
Provide a short and direct response. -0.67. What is the difference between the Expenditure(as % of GDP) of Azerbaijan in 2007 and the Expenditure(as % of GDP) of Jordan in 2008?
Offer a terse response. -3.68. What is the difference between the Expenditure(as % of GDP) of Grenada in 2007 and the Expenditure(as % of GDP) of Jordan in 2008?
Make the answer very short. -2.9. What is the difference between the Expenditure(as % of GDP) of Caribbean small states in 2007 and the Expenditure(as % of GDP) of Azerbaijan in 2009?
Offer a terse response. -0.54. What is the difference between the Expenditure(as % of GDP) of Caribbean small states in 2007 and the Expenditure(as % of GDP) of Grenada in 2009?
Keep it short and to the point. -0.93. What is the difference between the Expenditure(as % of GDP) of Caribbean small states in 2007 and the Expenditure(as % of GDP) of Jordan in 2009?
Your answer should be compact. -4.23. What is the difference between the Expenditure(as % of GDP) in Azerbaijan in 2007 and the Expenditure(as % of GDP) in Grenada in 2009?
Provide a succinct answer. -1.15. What is the difference between the Expenditure(as % of GDP) in Azerbaijan in 2007 and the Expenditure(as % of GDP) in Jordan in 2009?
Offer a terse response. -4.45. What is the difference between the Expenditure(as % of GDP) of Grenada in 2007 and the Expenditure(as % of GDP) of Jordan in 2009?
Provide a short and direct response. -3.67. What is the difference between the Expenditure(as % of GDP) of Caribbean small states in 2007 and the Expenditure(as % of GDP) of Azerbaijan in 2010?
Offer a very short reply. -0.02. What is the difference between the Expenditure(as % of GDP) of Caribbean small states in 2007 and the Expenditure(as % of GDP) of Grenada in 2010?
Keep it short and to the point. -1.05. What is the difference between the Expenditure(as % of GDP) of Caribbean small states in 2007 and the Expenditure(as % of GDP) of Jordan in 2010?
Ensure brevity in your answer.  -3.44. What is the difference between the Expenditure(as % of GDP) of Azerbaijan in 2007 and the Expenditure(as % of GDP) of Grenada in 2010?
Your answer should be very brief. -1.27. What is the difference between the Expenditure(as % of GDP) of Azerbaijan in 2007 and the Expenditure(as % of GDP) of Jordan in 2010?
Give a very brief answer. -3.66. What is the difference between the Expenditure(as % of GDP) of Grenada in 2007 and the Expenditure(as % of GDP) of Jordan in 2010?
Your answer should be compact. -2.88. What is the difference between the Expenditure(as % of GDP) of Caribbean small states in 2008 and the Expenditure(as % of GDP) of Azerbaijan in 2009?
Your answer should be very brief. -0.52. What is the difference between the Expenditure(as % of GDP) in Caribbean small states in 2008 and the Expenditure(as % of GDP) in Grenada in 2009?
Make the answer very short. -0.92. What is the difference between the Expenditure(as % of GDP) in Caribbean small states in 2008 and the Expenditure(as % of GDP) in Jordan in 2009?
Your answer should be compact. -4.22. What is the difference between the Expenditure(as % of GDP) of Azerbaijan in 2008 and the Expenditure(as % of GDP) of Grenada in 2009?
Provide a short and direct response. -1.87. What is the difference between the Expenditure(as % of GDP) of Azerbaijan in 2008 and the Expenditure(as % of GDP) of Jordan in 2009?
Give a very brief answer. -5.17. What is the difference between the Expenditure(as % of GDP) in Grenada in 2008 and the Expenditure(as % of GDP) in Jordan in 2009?
Give a very brief answer. -3.78. What is the difference between the Expenditure(as % of GDP) of Caribbean small states in 2008 and the Expenditure(as % of GDP) of Azerbaijan in 2010?
Make the answer very short. -0.01. What is the difference between the Expenditure(as % of GDP) in Caribbean small states in 2008 and the Expenditure(as % of GDP) in Grenada in 2010?
Your answer should be very brief. -1.04. What is the difference between the Expenditure(as % of GDP) in Caribbean small states in 2008 and the Expenditure(as % of GDP) in Jordan in 2010?
Keep it short and to the point. -3.43. What is the difference between the Expenditure(as % of GDP) of Azerbaijan in 2008 and the Expenditure(as % of GDP) of Grenada in 2010?
Offer a very short reply. -1.99. What is the difference between the Expenditure(as % of GDP) in Azerbaijan in 2008 and the Expenditure(as % of GDP) in Jordan in 2010?
Offer a very short reply. -4.38. What is the difference between the Expenditure(as % of GDP) in Grenada in 2008 and the Expenditure(as % of GDP) in Jordan in 2010?
Provide a short and direct response. -2.99. What is the difference between the Expenditure(as % of GDP) of Caribbean small states in 2009 and the Expenditure(as % of GDP) of Azerbaijan in 2010?
Provide a succinct answer. 0.79. What is the difference between the Expenditure(as % of GDP) of Caribbean small states in 2009 and the Expenditure(as % of GDP) of Grenada in 2010?
Your answer should be very brief. -0.24. What is the difference between the Expenditure(as % of GDP) in Caribbean small states in 2009 and the Expenditure(as % of GDP) in Jordan in 2010?
Make the answer very short. -2.63. What is the difference between the Expenditure(as % of GDP) in Azerbaijan in 2009 and the Expenditure(as % of GDP) in Grenada in 2010?
Give a very brief answer. -0.51. What is the difference between the Expenditure(as % of GDP) in Azerbaijan in 2009 and the Expenditure(as % of GDP) in Jordan in 2010?
Give a very brief answer. -2.9. What is the difference between the Expenditure(as % of GDP) of Grenada in 2009 and the Expenditure(as % of GDP) of Jordan in 2010?
Keep it short and to the point. -2.51. What is the average Expenditure(as % of GDP) of Caribbean small states per year?
Offer a very short reply. 5.39. What is the average Expenditure(as % of GDP) in Azerbaijan per year?
Your answer should be compact. 6.15. What is the average Expenditure(as % of GDP) of Grenada per year?
Ensure brevity in your answer.  5.84. What is the average Expenditure(as % of GDP) in Jordan per year?
Your answer should be compact. 8.83. In the year 2003, what is the difference between the Expenditure(as % of GDP) in Caribbean small states and Expenditure(as % of GDP) in Azerbaijan?
Make the answer very short. -1.4. In the year 2003, what is the difference between the Expenditure(as % of GDP) in Caribbean small states and Expenditure(as % of GDP) in Grenada?
Your answer should be very brief. -0.67. In the year 2003, what is the difference between the Expenditure(as % of GDP) of Caribbean small states and Expenditure(as % of GDP) of Jordan?
Your response must be concise. -3.99. In the year 2003, what is the difference between the Expenditure(as % of GDP) in Azerbaijan and Expenditure(as % of GDP) in Grenada?
Your answer should be very brief. 0.72. In the year 2003, what is the difference between the Expenditure(as % of GDP) of Azerbaijan and Expenditure(as % of GDP) of Jordan?
Offer a terse response. -2.59. In the year 2003, what is the difference between the Expenditure(as % of GDP) in Grenada and Expenditure(as % of GDP) in Jordan?
Your response must be concise. -3.31. In the year 2004, what is the difference between the Expenditure(as % of GDP) in Caribbean small states and Expenditure(as % of GDP) in Azerbaijan?
Ensure brevity in your answer.  -2.62. In the year 2004, what is the difference between the Expenditure(as % of GDP) of Caribbean small states and Expenditure(as % of GDP) of Grenada?
Offer a very short reply. 0.08. In the year 2004, what is the difference between the Expenditure(as % of GDP) in Caribbean small states and Expenditure(as % of GDP) in Jordan?
Keep it short and to the point. -3.76. In the year 2004, what is the difference between the Expenditure(as % of GDP) of Azerbaijan and Expenditure(as % of GDP) of Grenada?
Make the answer very short. 2.7. In the year 2004, what is the difference between the Expenditure(as % of GDP) of Azerbaijan and Expenditure(as % of GDP) of Jordan?
Provide a succinct answer. -1.14. In the year 2004, what is the difference between the Expenditure(as % of GDP) in Grenada and Expenditure(as % of GDP) in Jordan?
Provide a succinct answer. -3.84. In the year 2005, what is the difference between the Expenditure(as % of GDP) in Caribbean small states and Expenditure(as % of GDP) in Azerbaijan?
Keep it short and to the point. -2.75. In the year 2005, what is the difference between the Expenditure(as % of GDP) in Caribbean small states and Expenditure(as % of GDP) in Grenada?
Give a very brief answer. -0.37. In the year 2005, what is the difference between the Expenditure(as % of GDP) of Caribbean small states and Expenditure(as % of GDP) of Jordan?
Your answer should be very brief. -3.77. In the year 2005, what is the difference between the Expenditure(as % of GDP) in Azerbaijan and Expenditure(as % of GDP) in Grenada?
Provide a succinct answer. 2.38. In the year 2005, what is the difference between the Expenditure(as % of GDP) of Azerbaijan and Expenditure(as % of GDP) of Jordan?
Offer a very short reply. -1.02. In the year 2005, what is the difference between the Expenditure(as % of GDP) in Grenada and Expenditure(as % of GDP) in Jordan?
Your answer should be compact. -3.4. In the year 2006, what is the difference between the Expenditure(as % of GDP) in Caribbean small states and Expenditure(as % of GDP) in Azerbaijan?
Your response must be concise. -1.19. In the year 2006, what is the difference between the Expenditure(as % of GDP) in Caribbean small states and Expenditure(as % of GDP) in Grenada?
Offer a terse response. -0.98. In the year 2006, what is the difference between the Expenditure(as % of GDP) of Caribbean small states and Expenditure(as % of GDP) of Jordan?
Your answer should be very brief. -3.1. In the year 2006, what is the difference between the Expenditure(as % of GDP) in Azerbaijan and Expenditure(as % of GDP) in Grenada?
Your response must be concise. 0.2. In the year 2006, what is the difference between the Expenditure(as % of GDP) in Azerbaijan and Expenditure(as % of GDP) in Jordan?
Your answer should be very brief. -1.92. In the year 2006, what is the difference between the Expenditure(as % of GDP) in Grenada and Expenditure(as % of GDP) in Jordan?
Give a very brief answer. -2.12. In the year 2007, what is the difference between the Expenditure(as % of GDP) of Caribbean small states and Expenditure(as % of GDP) of Azerbaijan?
Your answer should be compact. 0.22. In the year 2007, what is the difference between the Expenditure(as % of GDP) of Caribbean small states and Expenditure(as % of GDP) of Grenada?
Your response must be concise. -0.56. In the year 2007, what is the difference between the Expenditure(as % of GDP) in Caribbean small states and Expenditure(as % of GDP) in Jordan?
Offer a terse response. -3.03. In the year 2007, what is the difference between the Expenditure(as % of GDP) in Azerbaijan and Expenditure(as % of GDP) in Grenada?
Offer a terse response. -0.78. In the year 2007, what is the difference between the Expenditure(as % of GDP) of Azerbaijan and Expenditure(as % of GDP) of Jordan?
Your response must be concise. -3.25. In the year 2007, what is the difference between the Expenditure(as % of GDP) in Grenada and Expenditure(as % of GDP) in Jordan?
Your answer should be very brief. -2.47. In the year 2008, what is the difference between the Expenditure(as % of GDP) in Caribbean small states and Expenditure(as % of GDP) in Azerbaijan?
Make the answer very short. 0.95. In the year 2008, what is the difference between the Expenditure(as % of GDP) in Caribbean small states and Expenditure(as % of GDP) in Grenada?
Offer a very short reply. -0.44. In the year 2008, what is the difference between the Expenditure(as % of GDP) in Caribbean small states and Expenditure(as % of GDP) in Jordan?
Your response must be concise. -3.45. In the year 2008, what is the difference between the Expenditure(as % of GDP) in Azerbaijan and Expenditure(as % of GDP) in Grenada?
Ensure brevity in your answer.  -1.39. In the year 2008, what is the difference between the Expenditure(as % of GDP) of Azerbaijan and Expenditure(as % of GDP) of Jordan?
Your response must be concise. -4.4. In the year 2008, what is the difference between the Expenditure(as % of GDP) of Grenada and Expenditure(as % of GDP) of Jordan?
Keep it short and to the point. -3.01. In the year 2009, what is the difference between the Expenditure(as % of GDP) of Caribbean small states and Expenditure(as % of GDP) of Azerbaijan?
Your response must be concise. 0.27. In the year 2009, what is the difference between the Expenditure(as % of GDP) of Caribbean small states and Expenditure(as % of GDP) of Grenada?
Offer a terse response. -0.12. In the year 2009, what is the difference between the Expenditure(as % of GDP) in Caribbean small states and Expenditure(as % of GDP) in Jordan?
Your answer should be compact. -3.42. In the year 2009, what is the difference between the Expenditure(as % of GDP) in Azerbaijan and Expenditure(as % of GDP) in Grenada?
Offer a very short reply. -0.39. In the year 2009, what is the difference between the Expenditure(as % of GDP) of Azerbaijan and Expenditure(as % of GDP) of Jordan?
Keep it short and to the point. -3.69. In the year 2009, what is the difference between the Expenditure(as % of GDP) in Grenada and Expenditure(as % of GDP) in Jordan?
Ensure brevity in your answer.  -3.3. In the year 2010, what is the difference between the Expenditure(as % of GDP) of Caribbean small states and Expenditure(as % of GDP) of Azerbaijan?
Offer a terse response. 0.44. In the year 2010, what is the difference between the Expenditure(as % of GDP) of Caribbean small states and Expenditure(as % of GDP) of Grenada?
Provide a succinct answer. -0.59. In the year 2010, what is the difference between the Expenditure(as % of GDP) of Caribbean small states and Expenditure(as % of GDP) of Jordan?
Ensure brevity in your answer.  -2.98. In the year 2010, what is the difference between the Expenditure(as % of GDP) of Azerbaijan and Expenditure(as % of GDP) of Grenada?
Your answer should be compact. -1.03. In the year 2010, what is the difference between the Expenditure(as % of GDP) of Azerbaijan and Expenditure(as % of GDP) of Jordan?
Ensure brevity in your answer.  -3.42. In the year 2010, what is the difference between the Expenditure(as % of GDP) in Grenada and Expenditure(as % of GDP) in Jordan?
Offer a terse response. -2.39. What is the ratio of the Expenditure(as % of GDP) in Caribbean small states in 2003 to that in 2004?
Keep it short and to the point. 0.97. What is the ratio of the Expenditure(as % of GDP) of Azerbaijan in 2003 to that in 2004?
Keep it short and to the point. 0.83. What is the ratio of the Expenditure(as % of GDP) of Grenada in 2003 to that in 2004?
Your answer should be very brief. 1.12. What is the ratio of the Expenditure(as % of GDP) of Jordan in 2003 to that in 2004?
Your answer should be compact. 1.01. What is the ratio of the Expenditure(as % of GDP) of Caribbean small states in 2003 to that in 2005?
Your answer should be very brief. 1.01. What is the ratio of the Expenditure(as % of GDP) of Azerbaijan in 2003 to that in 2005?
Provide a succinct answer. 0.83. What is the ratio of the Expenditure(as % of GDP) in Grenada in 2003 to that in 2005?
Ensure brevity in your answer.  1.07. What is the ratio of the Expenditure(as % of GDP) in Jordan in 2003 to that in 2005?
Ensure brevity in your answer.  1.03. What is the ratio of the Expenditure(as % of GDP) in Caribbean small states in 2003 to that in 2006?
Make the answer very short. 1.04. What is the ratio of the Expenditure(as % of GDP) in Azerbaijan in 2003 to that in 2006?
Your answer should be compact. 1.06. What is the ratio of the Expenditure(as % of GDP) of Grenada in 2003 to that in 2006?
Offer a very short reply. 0.98. What is the ratio of the Expenditure(as % of GDP) of Jordan in 2003 to that in 2006?
Your answer should be compact. 1.13. What is the ratio of the Expenditure(as % of GDP) in Caribbean small states in 2003 to that in 2007?
Make the answer very short. 0.97. What is the ratio of the Expenditure(as % of GDP) in Azerbaijan in 2003 to that in 2007?
Ensure brevity in your answer.  1.29. What is the ratio of the Expenditure(as % of GDP) in Grenada in 2003 to that in 2007?
Ensure brevity in your answer.  0.99. What is the ratio of the Expenditure(as % of GDP) of Jordan in 2003 to that in 2007?
Your answer should be very brief. 1.1. What is the ratio of the Expenditure(as % of GDP) of Caribbean small states in 2003 to that in 2008?
Offer a very short reply. 0.97. What is the ratio of the Expenditure(as % of GDP) of Azerbaijan in 2003 to that in 2008?
Your response must be concise. 1.5. What is the ratio of the Expenditure(as % of GDP) in Grenada in 2003 to that in 2008?
Provide a succinct answer. 1.01. What is the ratio of the Expenditure(as % of GDP) of Jordan in 2003 to that in 2008?
Your answer should be very brief. 1.04. What is the ratio of the Expenditure(as % of GDP) in Caribbean small states in 2003 to that in 2009?
Make the answer very short. 0.84. What is the ratio of the Expenditure(as % of GDP) in Azerbaijan in 2003 to that in 2009?
Make the answer very short. 1.12. What is the ratio of the Expenditure(as % of GDP) in Grenada in 2003 to that in 2009?
Your answer should be very brief. 0.94. What is the ratio of the Expenditure(as % of GDP) in Jordan in 2003 to that in 2009?
Your answer should be very brief. 0.96. What is the ratio of the Expenditure(as % of GDP) of Caribbean small states in 2003 to that in 2010?
Your answer should be compact. 0.9. What is the ratio of the Expenditure(as % of GDP) in Azerbaijan in 2003 to that in 2010?
Offer a terse response. 1.23. What is the ratio of the Expenditure(as % of GDP) of Grenada in 2003 to that in 2010?
Your answer should be compact. 0.92. What is the ratio of the Expenditure(as % of GDP) in Jordan in 2003 to that in 2010?
Offer a very short reply. 1.05. What is the ratio of the Expenditure(as % of GDP) of Caribbean small states in 2004 to that in 2005?
Your response must be concise. 1.04. What is the ratio of the Expenditure(as % of GDP) of Grenada in 2004 to that in 2005?
Offer a terse response. 0.95. What is the ratio of the Expenditure(as % of GDP) in Jordan in 2004 to that in 2005?
Your response must be concise. 1.02. What is the ratio of the Expenditure(as % of GDP) of Caribbean small states in 2004 to that in 2006?
Provide a short and direct response. 1.06. What is the ratio of the Expenditure(as % of GDP) in Azerbaijan in 2004 to that in 2006?
Keep it short and to the point. 1.28. What is the ratio of the Expenditure(as % of GDP) in Grenada in 2004 to that in 2006?
Make the answer very short. 0.88. What is the ratio of the Expenditure(as % of GDP) in Jordan in 2004 to that in 2006?
Make the answer very short. 1.12. What is the ratio of the Expenditure(as % of GDP) in Azerbaijan in 2004 to that in 2007?
Offer a very short reply. 1.56. What is the ratio of the Expenditure(as % of GDP) in Grenada in 2004 to that in 2007?
Your answer should be very brief. 0.89. What is the ratio of the Expenditure(as % of GDP) in Jordan in 2004 to that in 2007?
Your response must be concise. 1.09. What is the ratio of the Expenditure(as % of GDP) in Azerbaijan in 2004 to that in 2008?
Keep it short and to the point. 1.81. What is the ratio of the Expenditure(as % of GDP) in Grenada in 2004 to that in 2008?
Your answer should be very brief. 0.91. What is the ratio of the Expenditure(as % of GDP) in Jordan in 2004 to that in 2008?
Provide a succinct answer. 1.03. What is the ratio of the Expenditure(as % of GDP) in Caribbean small states in 2004 to that in 2009?
Offer a very short reply. 0.87. What is the ratio of the Expenditure(as % of GDP) of Azerbaijan in 2004 to that in 2009?
Keep it short and to the point. 1.35. What is the ratio of the Expenditure(as % of GDP) of Grenada in 2004 to that in 2009?
Make the answer very short. 0.84. What is the ratio of the Expenditure(as % of GDP) of Caribbean small states in 2004 to that in 2010?
Offer a terse response. 0.92. What is the ratio of the Expenditure(as % of GDP) of Azerbaijan in 2004 to that in 2010?
Offer a very short reply. 1.49. What is the ratio of the Expenditure(as % of GDP) in Grenada in 2004 to that in 2010?
Ensure brevity in your answer.  0.82. What is the ratio of the Expenditure(as % of GDP) of Jordan in 2004 to that in 2010?
Ensure brevity in your answer.  1.04. What is the ratio of the Expenditure(as % of GDP) in Caribbean small states in 2005 to that in 2006?
Offer a terse response. 1.03. What is the ratio of the Expenditure(as % of GDP) of Azerbaijan in 2005 to that in 2006?
Ensure brevity in your answer.  1.27. What is the ratio of the Expenditure(as % of GDP) in Grenada in 2005 to that in 2006?
Provide a succinct answer. 0.92. What is the ratio of the Expenditure(as % of GDP) of Jordan in 2005 to that in 2006?
Give a very brief answer. 1.1. What is the ratio of the Expenditure(as % of GDP) of Caribbean small states in 2005 to that in 2007?
Your answer should be compact. 0.96. What is the ratio of the Expenditure(as % of GDP) of Azerbaijan in 2005 to that in 2007?
Keep it short and to the point. 1.54. What is the ratio of the Expenditure(as % of GDP) of Grenada in 2005 to that in 2007?
Provide a succinct answer. 0.93. What is the ratio of the Expenditure(as % of GDP) in Jordan in 2005 to that in 2007?
Provide a succinct answer. 1.06. What is the ratio of the Expenditure(as % of GDP) of Caribbean small states in 2005 to that in 2008?
Give a very brief answer. 0.96. What is the ratio of the Expenditure(as % of GDP) of Azerbaijan in 2005 to that in 2008?
Provide a short and direct response. 1.8. What is the ratio of the Expenditure(as % of GDP) of Grenada in 2005 to that in 2008?
Provide a succinct answer. 0.95. What is the ratio of the Expenditure(as % of GDP) in Jordan in 2005 to that in 2008?
Give a very brief answer. 1.01. What is the ratio of the Expenditure(as % of GDP) of Caribbean small states in 2005 to that in 2009?
Keep it short and to the point. 0.83. What is the ratio of the Expenditure(as % of GDP) in Azerbaijan in 2005 to that in 2009?
Ensure brevity in your answer.  1.34. What is the ratio of the Expenditure(as % of GDP) in Grenada in 2005 to that in 2009?
Your answer should be compact. 0.88. What is the ratio of the Expenditure(as % of GDP) of Jordan in 2005 to that in 2009?
Your answer should be very brief. 0.93. What is the ratio of the Expenditure(as % of GDP) in Caribbean small states in 2005 to that in 2010?
Provide a succinct answer. 0.89. What is the ratio of the Expenditure(as % of GDP) of Azerbaijan in 2005 to that in 2010?
Make the answer very short. 1.47. What is the ratio of the Expenditure(as % of GDP) of Grenada in 2005 to that in 2010?
Provide a short and direct response. 0.86. What is the ratio of the Expenditure(as % of GDP) of Jordan in 2005 to that in 2010?
Offer a very short reply. 1.01. What is the ratio of the Expenditure(as % of GDP) in Caribbean small states in 2006 to that in 2007?
Offer a very short reply. 0.94. What is the ratio of the Expenditure(as % of GDP) of Azerbaijan in 2006 to that in 2007?
Keep it short and to the point. 1.21. What is the ratio of the Expenditure(as % of GDP) in Grenada in 2006 to that in 2007?
Offer a very short reply. 1.02. What is the ratio of the Expenditure(as % of GDP) of Jordan in 2006 to that in 2007?
Ensure brevity in your answer.  0.97. What is the ratio of the Expenditure(as % of GDP) in Caribbean small states in 2006 to that in 2008?
Ensure brevity in your answer.  0.94. What is the ratio of the Expenditure(as % of GDP) in Azerbaijan in 2006 to that in 2008?
Your response must be concise. 1.41. What is the ratio of the Expenditure(as % of GDP) of Grenada in 2006 to that in 2008?
Offer a very short reply. 1.03. What is the ratio of the Expenditure(as % of GDP) in Jordan in 2006 to that in 2008?
Provide a succinct answer. 0.92. What is the ratio of the Expenditure(as % of GDP) in Caribbean small states in 2006 to that in 2009?
Ensure brevity in your answer.  0.81. What is the ratio of the Expenditure(as % of GDP) of Azerbaijan in 2006 to that in 2009?
Offer a terse response. 1.05. What is the ratio of the Expenditure(as % of GDP) in Grenada in 2006 to that in 2009?
Make the answer very short. 0.96. What is the ratio of the Expenditure(as % of GDP) in Jordan in 2006 to that in 2009?
Ensure brevity in your answer.  0.85. What is the ratio of the Expenditure(as % of GDP) of Caribbean small states in 2006 to that in 2010?
Make the answer very short. 0.86. What is the ratio of the Expenditure(as % of GDP) in Azerbaijan in 2006 to that in 2010?
Keep it short and to the point. 1.16. What is the ratio of the Expenditure(as % of GDP) in Grenada in 2006 to that in 2010?
Offer a terse response. 0.94. What is the ratio of the Expenditure(as % of GDP) in Jordan in 2006 to that in 2010?
Your answer should be compact. 0.92. What is the ratio of the Expenditure(as % of GDP) in Azerbaijan in 2007 to that in 2008?
Keep it short and to the point. 1.16. What is the ratio of the Expenditure(as % of GDP) in Grenada in 2007 to that in 2008?
Make the answer very short. 1.02. What is the ratio of the Expenditure(as % of GDP) in Jordan in 2007 to that in 2008?
Your answer should be very brief. 0.95. What is the ratio of the Expenditure(as % of GDP) of Caribbean small states in 2007 to that in 2009?
Offer a very short reply. 0.87. What is the ratio of the Expenditure(as % of GDP) in Azerbaijan in 2007 to that in 2009?
Offer a terse response. 0.87. What is the ratio of the Expenditure(as % of GDP) of Grenada in 2007 to that in 2009?
Your response must be concise. 0.94. What is the ratio of the Expenditure(as % of GDP) of Jordan in 2007 to that in 2009?
Give a very brief answer. 0.87. What is the ratio of the Expenditure(as % of GDP) of Caribbean small states in 2007 to that in 2010?
Provide a succinct answer. 0.92. What is the ratio of the Expenditure(as % of GDP) of Azerbaijan in 2007 to that in 2010?
Offer a very short reply. 0.96. What is the ratio of the Expenditure(as % of GDP) in Grenada in 2007 to that in 2010?
Your answer should be compact. 0.92. What is the ratio of the Expenditure(as % of GDP) of Jordan in 2007 to that in 2010?
Provide a short and direct response. 0.95. What is the ratio of the Expenditure(as % of GDP) in Caribbean small states in 2008 to that in 2009?
Provide a short and direct response. 0.87. What is the ratio of the Expenditure(as % of GDP) in Azerbaijan in 2008 to that in 2009?
Your response must be concise. 0.75. What is the ratio of the Expenditure(as % of GDP) of Grenada in 2008 to that in 2009?
Ensure brevity in your answer.  0.92. What is the ratio of the Expenditure(as % of GDP) in Jordan in 2008 to that in 2009?
Offer a very short reply. 0.92. What is the ratio of the Expenditure(as % of GDP) in Caribbean small states in 2008 to that in 2010?
Your answer should be very brief. 0.92. What is the ratio of the Expenditure(as % of GDP) in Azerbaijan in 2008 to that in 2010?
Provide a short and direct response. 0.82. What is the ratio of the Expenditure(as % of GDP) of Grenada in 2008 to that in 2010?
Your response must be concise. 0.91. What is the ratio of the Expenditure(as % of GDP) in Caribbean small states in 2009 to that in 2010?
Offer a terse response. 1.06. What is the ratio of the Expenditure(as % of GDP) in Azerbaijan in 2009 to that in 2010?
Make the answer very short. 1.1. What is the ratio of the Expenditure(as % of GDP) in Jordan in 2009 to that in 2010?
Give a very brief answer. 1.09. What is the difference between the highest and the second highest Expenditure(as % of GDP) of Caribbean small states?
Make the answer very short. 0.35. What is the difference between the highest and the second highest Expenditure(as % of GDP) of Azerbaijan?
Offer a very short reply. 0.06. What is the difference between the highest and the second highest Expenditure(as % of GDP) in Grenada?
Keep it short and to the point. 0.12. What is the difference between the highest and the second highest Expenditure(as % of GDP) of Jordan?
Provide a short and direct response. 0.39. What is the difference between the highest and the lowest Expenditure(as % of GDP) in Caribbean small states?
Provide a succinct answer. 1.14. What is the difference between the highest and the lowest Expenditure(as % of GDP) of Azerbaijan?
Offer a very short reply. 3.55. What is the difference between the highest and the lowest Expenditure(as % of GDP) of Grenada?
Offer a very short reply. 1.14. What is the difference between the highest and the lowest Expenditure(as % of GDP) in Jordan?
Your response must be concise. 1.46. 